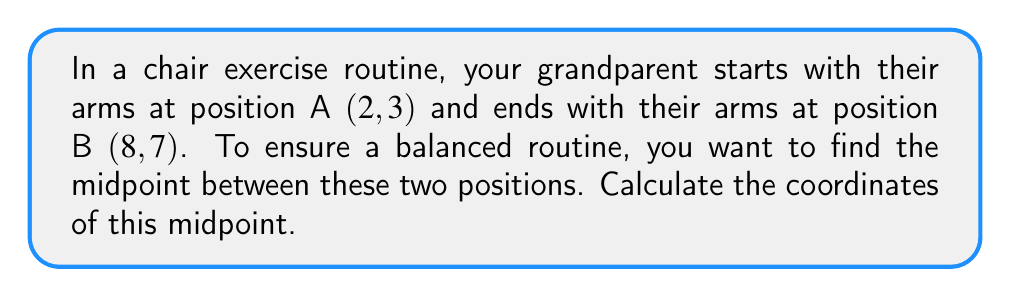Show me your answer to this math problem. To find the midpoint between two points, we use the midpoint formula:

$$ \text{Midpoint} = \left(\frac{x_1 + x_2}{2}, \frac{y_1 + y_2}{2}\right) $$

Where $(x_1, y_1)$ is the first point and $(x_2, y_2)$ is the second point.

Given:
- Point A: $(2, 3)$
- Point B: $(8, 7)$

Step 1: Calculate the x-coordinate of the midpoint:
$$ x = \frac{x_1 + x_2}{2} = \frac{2 + 8}{2} = \frac{10}{2} = 5 $$

Step 2: Calculate the y-coordinate of the midpoint:
$$ y = \frac{y_1 + y_2}{2} = \frac{3 + 7}{2} = \frac{10}{2} = 5 $$

Step 3: Combine the results to get the midpoint coordinates:
$$ \text{Midpoint} = (5, 5) $$

This point represents the balanced position between the starting and ending arm positions in the chair exercise routine.
Answer: $(5, 5)$ 